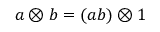Convert formula to latex. <formula><loc_0><loc_0><loc_500><loc_500>a \otimes b = ( a b ) \otimes 1</formula> 